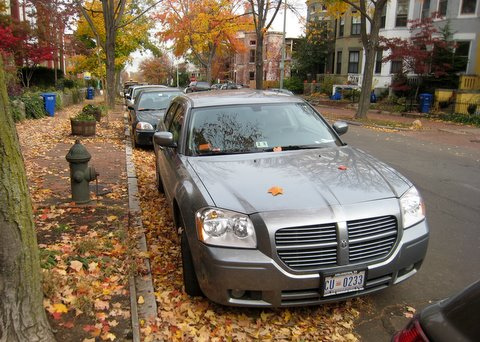Please transcribe the text in this image. CU 0233 